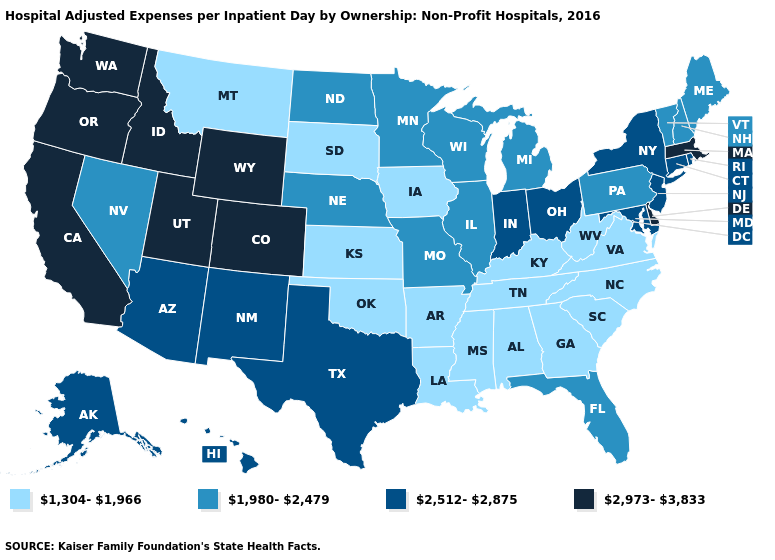What is the value of Hawaii?
Give a very brief answer. 2,512-2,875. Does Nebraska have a higher value than Hawaii?
Short answer required. No. Name the states that have a value in the range 1,304-1,966?
Concise answer only. Alabama, Arkansas, Georgia, Iowa, Kansas, Kentucky, Louisiana, Mississippi, Montana, North Carolina, Oklahoma, South Carolina, South Dakota, Tennessee, Virginia, West Virginia. What is the value of Delaware?
Keep it brief. 2,973-3,833. Name the states that have a value in the range 1,980-2,479?
Be succinct. Florida, Illinois, Maine, Michigan, Minnesota, Missouri, Nebraska, Nevada, New Hampshire, North Dakota, Pennsylvania, Vermont, Wisconsin. Among the states that border Alabama , does Florida have the highest value?
Concise answer only. Yes. Among the states that border Illinois , which have the lowest value?
Short answer required. Iowa, Kentucky. Does Minnesota have the highest value in the MidWest?
Short answer required. No. What is the highest value in states that border Iowa?
Quick response, please. 1,980-2,479. What is the highest value in the USA?
Short answer required. 2,973-3,833. Among the states that border Vermont , which have the lowest value?
Short answer required. New Hampshire. Does Massachusetts have the highest value in the USA?
Be succinct. Yes. Name the states that have a value in the range 1,980-2,479?
Write a very short answer. Florida, Illinois, Maine, Michigan, Minnesota, Missouri, Nebraska, Nevada, New Hampshire, North Dakota, Pennsylvania, Vermont, Wisconsin. Among the states that border Florida , which have the lowest value?
Write a very short answer. Alabama, Georgia. Name the states that have a value in the range 2,512-2,875?
Concise answer only. Alaska, Arizona, Connecticut, Hawaii, Indiana, Maryland, New Jersey, New Mexico, New York, Ohio, Rhode Island, Texas. 